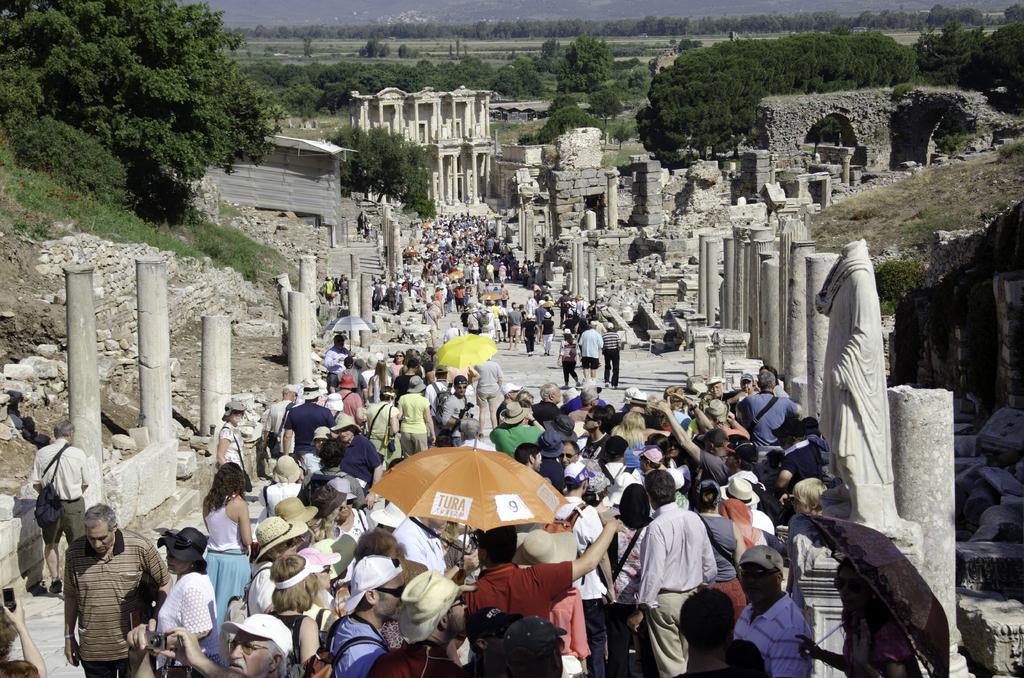Please provide a concise description of this image. In this image we can see few persons are standing and among them we can see few persons are holding umbrellas in their hands, carrying bags on the shoulders, trees and few persons have hearts on their heads and we can see pillars, statues, collapsed walls and building. In the background we can see trees on the ground. 